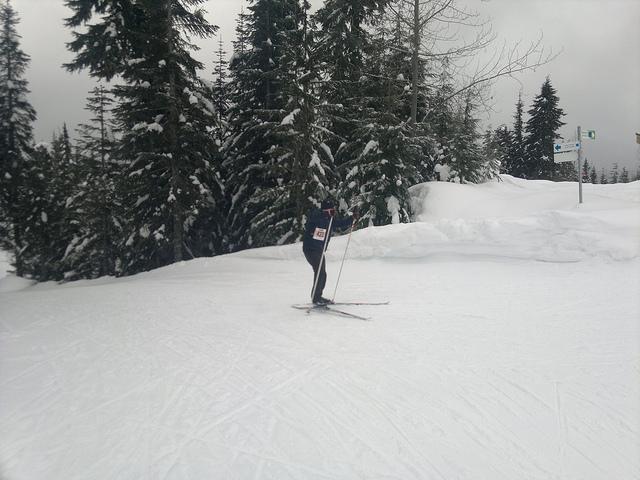How many people are skiing?
Give a very brief answer. 1. How many dogs are following the horse?
Give a very brief answer. 0. 